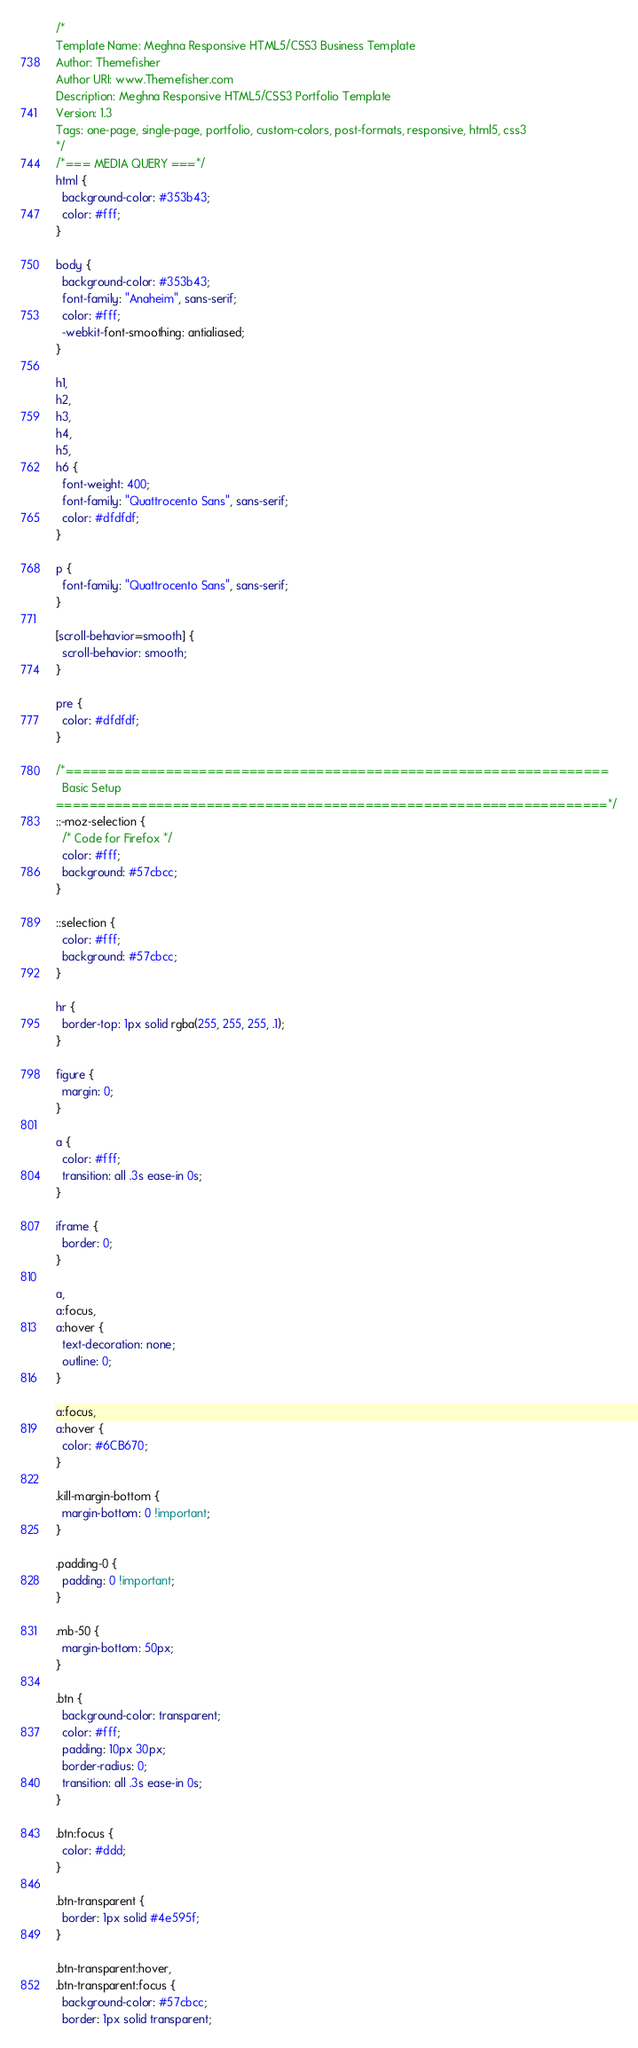<code> <loc_0><loc_0><loc_500><loc_500><_CSS_>/*
Template Name: Meghna Responsive HTML5/CSS3 Business Template
Author: Themefisher
Author URI: www.Themefisher.com
Description: Meghna Responsive HTML5/CSS3 Portfolio Template
Version: 1.3
Tags: one-page, single-page, portfolio, custom-colors, post-formats, responsive, html5, css3
*/
/*=== MEDIA QUERY ===*/
html {
  background-color: #353b43;
  color: #fff;
}

body {
  background-color: #353b43;
  font-family: "Anaheim", sans-serif;
  color: #fff;
  -webkit-font-smoothing: antialiased;
}

h1,
h2,
h3,
h4,
h5,
h6 {
  font-weight: 400;
  font-family: "Quattrocento Sans", sans-serif;
  color: #dfdfdf;
}

p {
  font-family: "Quattrocento Sans", sans-serif;
}

[scroll-behavior=smooth] {
  scroll-behavior: smooth;
}

pre {
  color: #dfdfdf;
}

/*=================================================================
  Basic Setup
==================================================================*/
::-moz-selection {
  /* Code for Firefox */
  color: #fff;
  background: #57cbcc;
}

::selection {
  color: #fff;
  background: #57cbcc;
}

hr {
  border-top: 1px solid rgba(255, 255, 255, .1);
}

figure {
  margin: 0;
}

a {
  color: #fff;
  transition: all .3s ease-in 0s;
}

iframe {
  border: 0;
}

a,
a:focus,
a:hover {
  text-decoration: none;
  outline: 0;
}

a:focus,
a:hover {
  color: #6CB670;
}

.kill-margin-bottom {
  margin-bottom: 0 !important;
}

.padding-0 {
  padding: 0 !important;
}

.mb-50 {
  margin-bottom: 50px;
}

.btn {
  background-color: transparent;
  color: #fff;
  padding: 10px 30px;
  border-radius: 0;
  transition: all .3s ease-in 0s;
}

.btn:focus {
  color: #ddd;
}

.btn-transparent {
  border: 1px solid #4e595f;
}

.btn-transparent:hover,
.btn-transparent:focus {
  background-color: #57cbcc;
  border: 1px solid transparent;</code> 